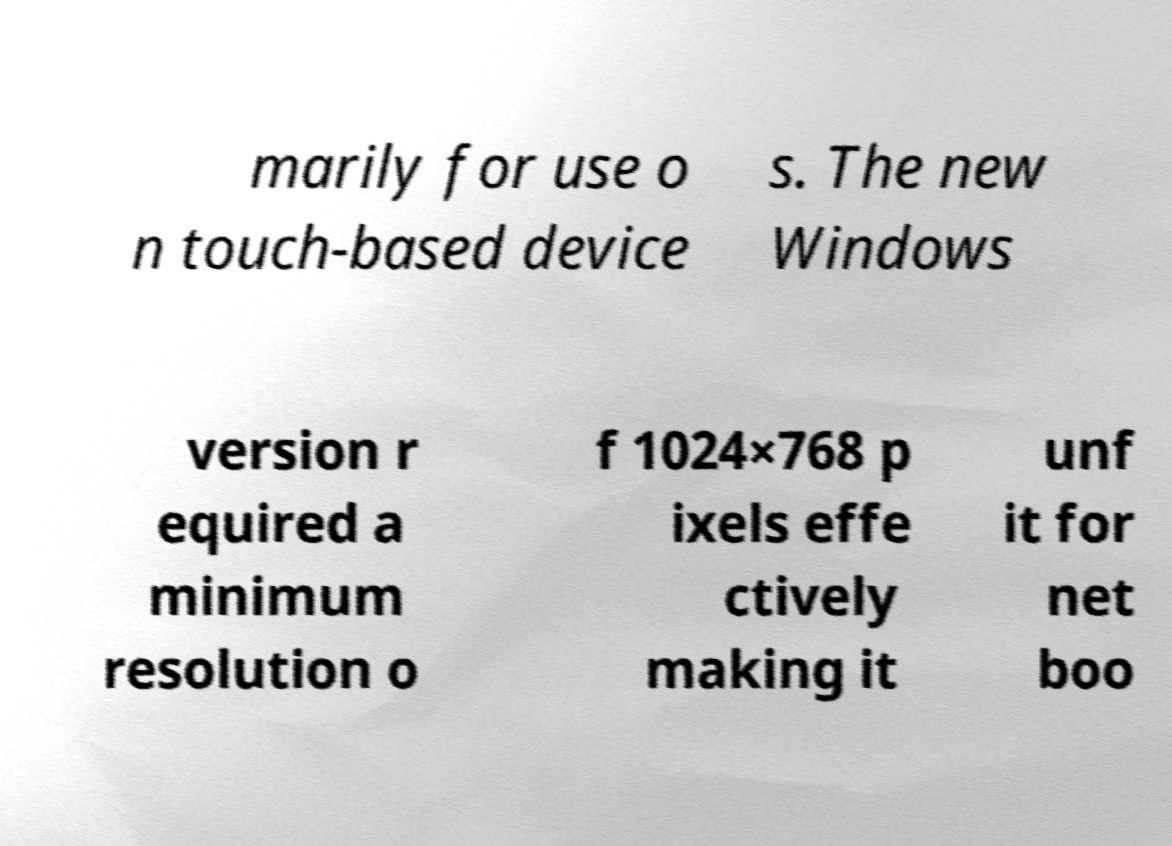For documentation purposes, I need the text within this image transcribed. Could you provide that? marily for use o n touch-based device s. The new Windows version r equired a minimum resolution o f 1024×768 p ixels effe ctively making it unf it for net boo 